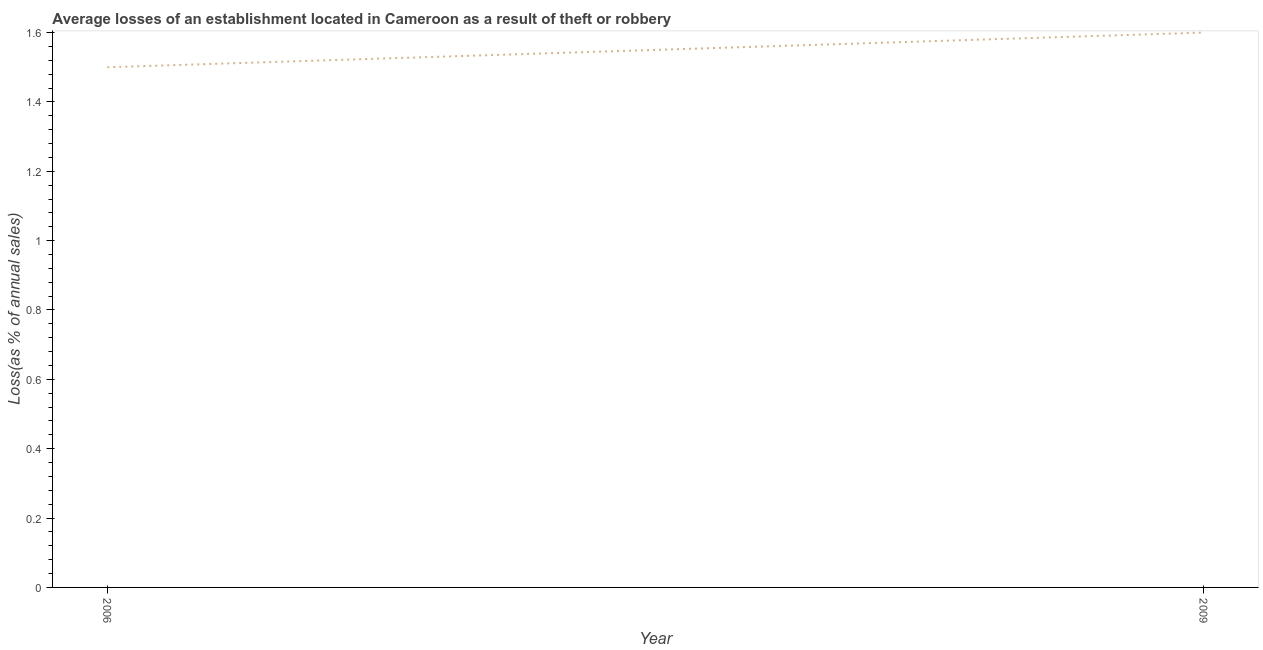What is the losses due to theft in 2006?
Offer a very short reply. 1.5. In which year was the losses due to theft maximum?
Ensure brevity in your answer.  2009. In which year was the losses due to theft minimum?
Ensure brevity in your answer.  2006. What is the sum of the losses due to theft?
Your response must be concise. 3.1. What is the difference between the losses due to theft in 2006 and 2009?
Provide a succinct answer. -0.1. What is the average losses due to theft per year?
Give a very brief answer. 1.55. What is the median losses due to theft?
Keep it short and to the point. 1.55. In how many years, is the losses due to theft greater than 0.7600000000000001 %?
Keep it short and to the point. 2. What is the ratio of the losses due to theft in 2006 to that in 2009?
Offer a very short reply. 0.94. Is the losses due to theft in 2006 less than that in 2009?
Provide a short and direct response. Yes. In how many years, is the losses due to theft greater than the average losses due to theft taken over all years?
Keep it short and to the point. 1. How many years are there in the graph?
Give a very brief answer. 2. What is the difference between two consecutive major ticks on the Y-axis?
Your response must be concise. 0.2. What is the title of the graph?
Provide a succinct answer. Average losses of an establishment located in Cameroon as a result of theft or robbery. What is the label or title of the Y-axis?
Give a very brief answer. Loss(as % of annual sales). What is the difference between the Loss(as % of annual sales) in 2006 and 2009?
Your answer should be compact. -0.1. What is the ratio of the Loss(as % of annual sales) in 2006 to that in 2009?
Give a very brief answer. 0.94. 